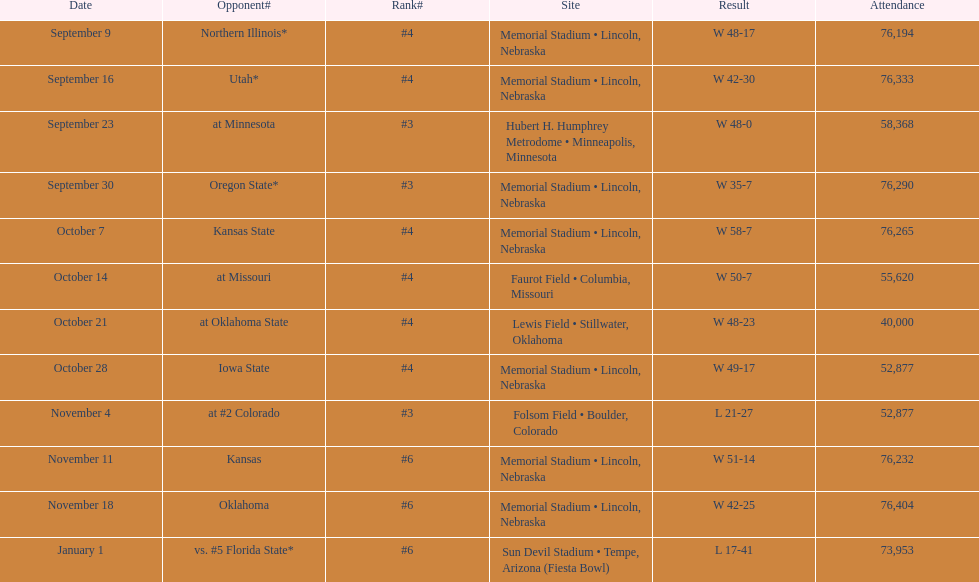What is the next site listed after lewis field? Memorial Stadium • Lincoln, Nebraska. 